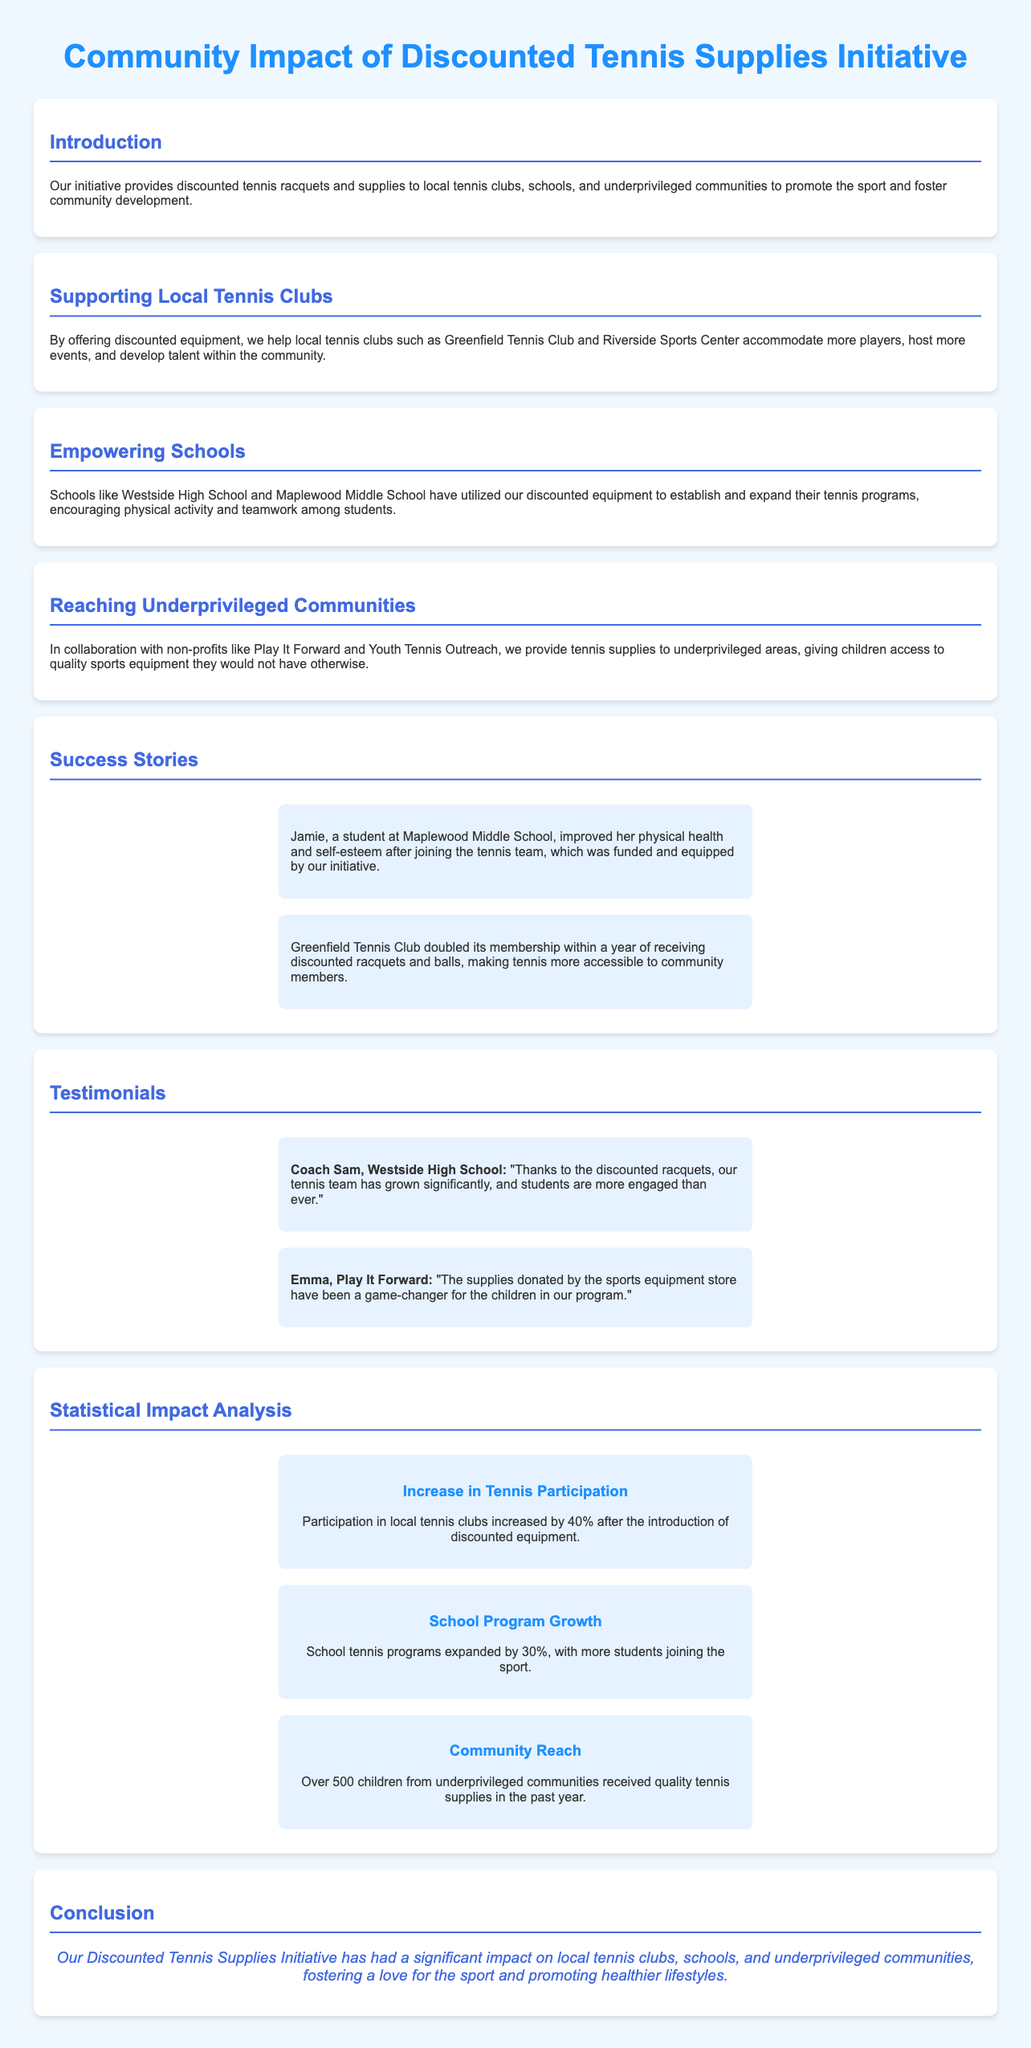what is the primary focus of the initiative? The initiative provides discounted tennis racquets and supplies to promote the sport and foster community development.
Answer: discounted tennis racquets and supplies which local tennis clubs benefitted from the initiative? The document mentions specific local tennis clubs that benefited, including Greenfield Tennis Club and Riverside Sports Center.
Answer: Greenfield Tennis Club and Riverside Sports Center how many children received tennis supplies from underprivileged communities last year? The document provides a statistical figure regarding children from underprivileged communities receiving supplies, which is indicated in the analysis.
Answer: Over 500 children what percentage increase in participation occurred at local tennis clubs? The percentage increase in participation at local tennis clubs as a result of the initiative is specified in the statistics section.
Answer: 40% who is quoted as saying the supplies were a game-changer? The document contains a testimonial about the impact of supplies on children in a program, specifically mentioning a name.
Answer: Emma what effect did the discounted equipment have on school tennis programs? The impact on school tennis programs is quantified in the document, indicating how much they expanded.
Answer: expanded by 30% what is one success story from the initiative? The document lists a success story involving a student who improved her physical health and self-esteem through the tennis team.
Answer: Jamie's improvement what is the concluding message of the initiative? The document summarizes the overall impact of the initiative at the end.
Answer: significant impact on local tennis clubs, schools, and underprivileged communities 